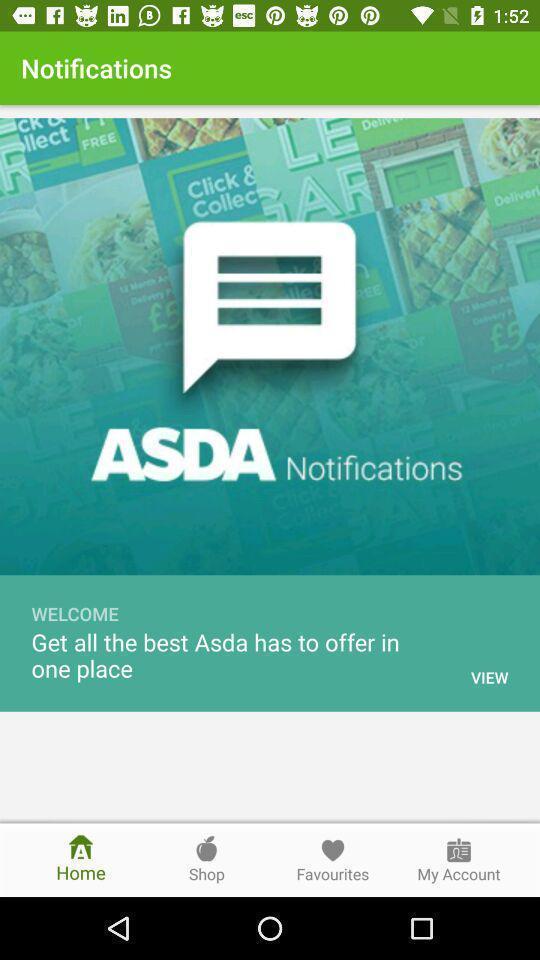Describe the visual elements of this screenshot. Welcome page. 